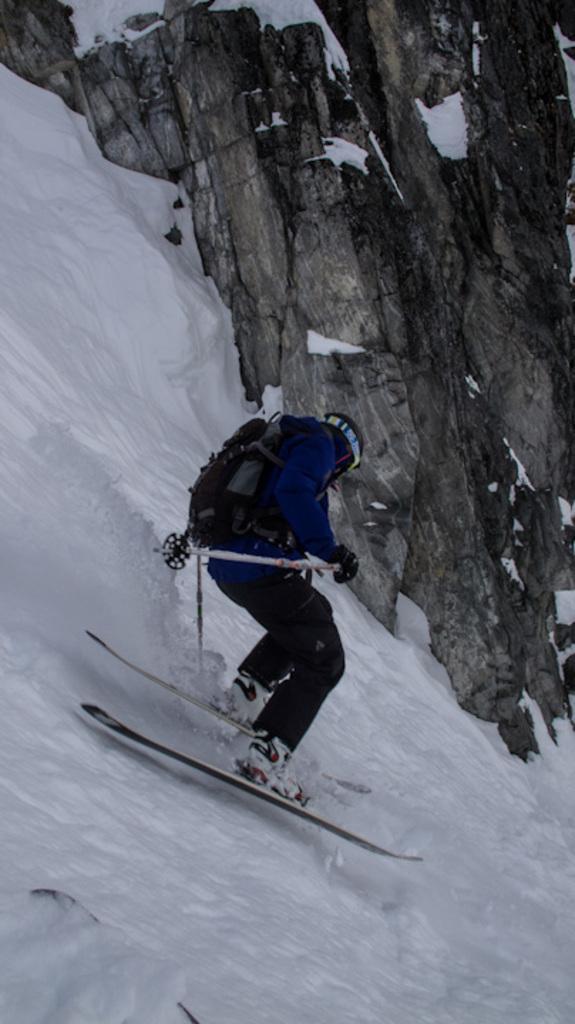Please provide a concise description of this image. In this image I can see a person wearing blue and black colored dress and black colored bag is on the ski boards and skiing on the snow. In the background I can see a huge rock and some snow on it. 